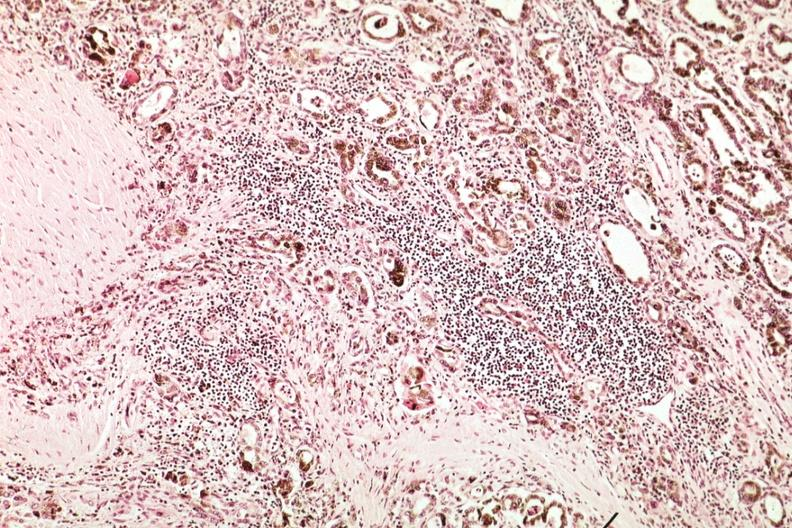s hemochromatosis present?
Answer the question using a single word or phrase. No 